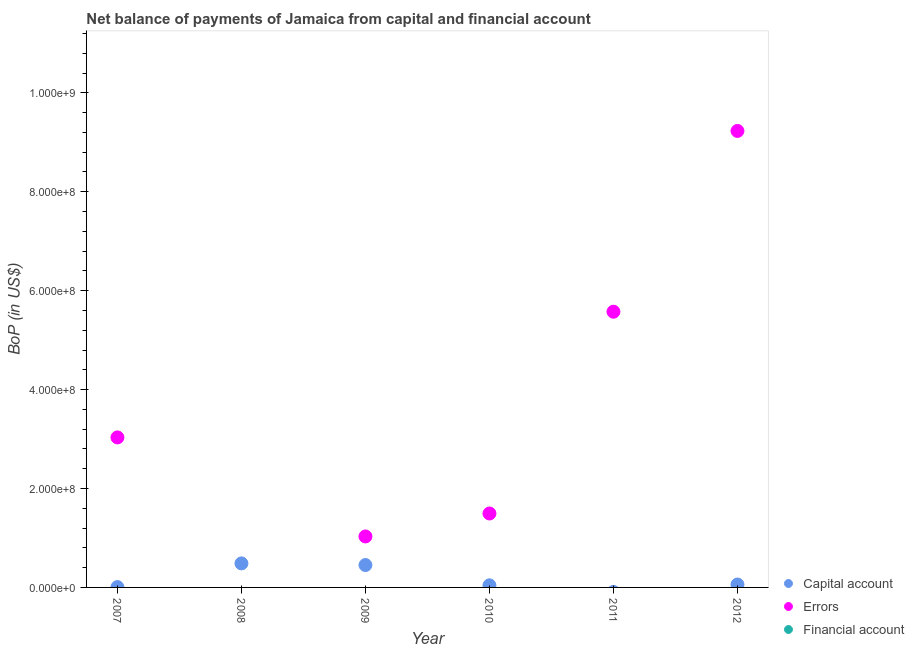Is the number of dotlines equal to the number of legend labels?
Make the answer very short. No. What is the amount of financial account in 2008?
Make the answer very short. 0. Across all years, what is the maximum amount of errors?
Provide a succinct answer. 9.23e+08. What is the total amount of net capital account in the graph?
Provide a succinct answer. 1.05e+08. What is the difference between the amount of errors in 2010 and that in 2012?
Your answer should be very brief. -7.73e+08. What is the difference between the amount of net capital account in 2007 and the amount of errors in 2009?
Offer a very short reply. -1.02e+08. What is the average amount of net capital account per year?
Offer a terse response. 1.74e+07. In the year 2010, what is the difference between the amount of net capital account and amount of errors?
Your answer should be very brief. -1.45e+08. In how many years, is the amount of net capital account greater than 120000000 US$?
Give a very brief answer. 0. What is the ratio of the amount of net capital account in 2008 to that in 2010?
Offer a very short reply. 11.45. What is the difference between the highest and the second highest amount of net capital account?
Keep it short and to the point. 3.31e+06. What is the difference between the highest and the lowest amount of net capital account?
Keep it short and to the point. 4.86e+07. Is it the case that in every year, the sum of the amount of net capital account and amount of errors is greater than the amount of financial account?
Offer a terse response. Yes. Does the amount of errors monotonically increase over the years?
Keep it short and to the point. No. Is the amount of net capital account strictly greater than the amount of financial account over the years?
Ensure brevity in your answer.  Yes. What is the difference between two consecutive major ticks on the Y-axis?
Your answer should be very brief. 2.00e+08. Are the values on the major ticks of Y-axis written in scientific E-notation?
Your answer should be compact. Yes. How many legend labels are there?
Ensure brevity in your answer.  3. What is the title of the graph?
Make the answer very short. Net balance of payments of Jamaica from capital and financial account. Does "Services" appear as one of the legend labels in the graph?
Your answer should be very brief. No. What is the label or title of the Y-axis?
Ensure brevity in your answer.  BoP (in US$). What is the BoP (in US$) in Capital account in 2007?
Make the answer very short. 6.90e+05. What is the BoP (in US$) in Errors in 2007?
Offer a terse response. 3.03e+08. What is the BoP (in US$) in Capital account in 2008?
Your answer should be compact. 4.86e+07. What is the BoP (in US$) in Capital account in 2009?
Give a very brief answer. 4.53e+07. What is the BoP (in US$) of Errors in 2009?
Provide a short and direct response. 1.03e+08. What is the BoP (in US$) in Financial account in 2009?
Provide a succinct answer. 0. What is the BoP (in US$) in Capital account in 2010?
Your answer should be compact. 4.24e+06. What is the BoP (in US$) in Errors in 2010?
Your answer should be very brief. 1.49e+08. What is the BoP (in US$) in Capital account in 2011?
Offer a terse response. 0. What is the BoP (in US$) in Errors in 2011?
Make the answer very short. 5.57e+08. What is the BoP (in US$) in Financial account in 2011?
Make the answer very short. 0. What is the BoP (in US$) of Capital account in 2012?
Offer a terse response. 5.87e+06. What is the BoP (in US$) of Errors in 2012?
Provide a short and direct response. 9.23e+08. What is the BoP (in US$) in Financial account in 2012?
Offer a very short reply. 0. Across all years, what is the maximum BoP (in US$) in Capital account?
Offer a very short reply. 4.86e+07. Across all years, what is the maximum BoP (in US$) in Errors?
Your answer should be very brief. 9.23e+08. Across all years, what is the minimum BoP (in US$) of Capital account?
Provide a succinct answer. 0. What is the total BoP (in US$) of Capital account in the graph?
Keep it short and to the point. 1.05e+08. What is the total BoP (in US$) in Errors in the graph?
Provide a short and direct response. 2.04e+09. What is the total BoP (in US$) in Financial account in the graph?
Provide a short and direct response. 0. What is the difference between the BoP (in US$) of Capital account in 2007 and that in 2008?
Make the answer very short. -4.79e+07. What is the difference between the BoP (in US$) in Capital account in 2007 and that in 2009?
Keep it short and to the point. -4.46e+07. What is the difference between the BoP (in US$) of Errors in 2007 and that in 2009?
Keep it short and to the point. 2.00e+08. What is the difference between the BoP (in US$) in Capital account in 2007 and that in 2010?
Offer a terse response. -3.55e+06. What is the difference between the BoP (in US$) in Errors in 2007 and that in 2010?
Offer a very short reply. 1.54e+08. What is the difference between the BoP (in US$) of Errors in 2007 and that in 2011?
Your answer should be compact. -2.54e+08. What is the difference between the BoP (in US$) in Capital account in 2007 and that in 2012?
Provide a succinct answer. -5.18e+06. What is the difference between the BoP (in US$) in Errors in 2007 and that in 2012?
Keep it short and to the point. -6.20e+08. What is the difference between the BoP (in US$) of Capital account in 2008 and that in 2009?
Provide a short and direct response. 3.31e+06. What is the difference between the BoP (in US$) of Capital account in 2008 and that in 2010?
Make the answer very short. 4.43e+07. What is the difference between the BoP (in US$) in Capital account in 2008 and that in 2012?
Ensure brevity in your answer.  4.27e+07. What is the difference between the BoP (in US$) in Capital account in 2009 and that in 2010?
Ensure brevity in your answer.  4.10e+07. What is the difference between the BoP (in US$) in Errors in 2009 and that in 2010?
Make the answer very short. -4.64e+07. What is the difference between the BoP (in US$) of Errors in 2009 and that in 2011?
Keep it short and to the point. -4.54e+08. What is the difference between the BoP (in US$) in Capital account in 2009 and that in 2012?
Offer a very short reply. 3.94e+07. What is the difference between the BoP (in US$) of Errors in 2009 and that in 2012?
Give a very brief answer. -8.20e+08. What is the difference between the BoP (in US$) in Errors in 2010 and that in 2011?
Provide a succinct answer. -4.08e+08. What is the difference between the BoP (in US$) in Capital account in 2010 and that in 2012?
Ensure brevity in your answer.  -1.63e+06. What is the difference between the BoP (in US$) in Errors in 2010 and that in 2012?
Your answer should be compact. -7.73e+08. What is the difference between the BoP (in US$) of Errors in 2011 and that in 2012?
Your answer should be compact. -3.65e+08. What is the difference between the BoP (in US$) of Capital account in 2007 and the BoP (in US$) of Errors in 2009?
Offer a terse response. -1.02e+08. What is the difference between the BoP (in US$) of Capital account in 2007 and the BoP (in US$) of Errors in 2010?
Your response must be concise. -1.49e+08. What is the difference between the BoP (in US$) in Capital account in 2007 and the BoP (in US$) in Errors in 2011?
Offer a very short reply. -5.57e+08. What is the difference between the BoP (in US$) of Capital account in 2007 and the BoP (in US$) of Errors in 2012?
Give a very brief answer. -9.22e+08. What is the difference between the BoP (in US$) in Capital account in 2008 and the BoP (in US$) in Errors in 2009?
Offer a terse response. -5.45e+07. What is the difference between the BoP (in US$) in Capital account in 2008 and the BoP (in US$) in Errors in 2010?
Keep it short and to the point. -1.01e+08. What is the difference between the BoP (in US$) of Capital account in 2008 and the BoP (in US$) of Errors in 2011?
Your answer should be very brief. -5.09e+08. What is the difference between the BoP (in US$) of Capital account in 2008 and the BoP (in US$) of Errors in 2012?
Your answer should be compact. -8.74e+08. What is the difference between the BoP (in US$) of Capital account in 2009 and the BoP (in US$) of Errors in 2010?
Provide a short and direct response. -1.04e+08. What is the difference between the BoP (in US$) of Capital account in 2009 and the BoP (in US$) of Errors in 2011?
Your answer should be compact. -5.12e+08. What is the difference between the BoP (in US$) of Capital account in 2009 and the BoP (in US$) of Errors in 2012?
Your answer should be very brief. -8.78e+08. What is the difference between the BoP (in US$) of Capital account in 2010 and the BoP (in US$) of Errors in 2011?
Your answer should be very brief. -5.53e+08. What is the difference between the BoP (in US$) of Capital account in 2010 and the BoP (in US$) of Errors in 2012?
Ensure brevity in your answer.  -9.19e+08. What is the average BoP (in US$) in Capital account per year?
Keep it short and to the point. 1.74e+07. What is the average BoP (in US$) of Errors per year?
Offer a very short reply. 3.39e+08. In the year 2007, what is the difference between the BoP (in US$) in Capital account and BoP (in US$) in Errors?
Provide a succinct answer. -3.03e+08. In the year 2009, what is the difference between the BoP (in US$) of Capital account and BoP (in US$) of Errors?
Your answer should be very brief. -5.78e+07. In the year 2010, what is the difference between the BoP (in US$) in Capital account and BoP (in US$) in Errors?
Your answer should be very brief. -1.45e+08. In the year 2012, what is the difference between the BoP (in US$) in Capital account and BoP (in US$) in Errors?
Keep it short and to the point. -9.17e+08. What is the ratio of the BoP (in US$) of Capital account in 2007 to that in 2008?
Make the answer very short. 0.01. What is the ratio of the BoP (in US$) of Capital account in 2007 to that in 2009?
Provide a succinct answer. 0.02. What is the ratio of the BoP (in US$) of Errors in 2007 to that in 2009?
Give a very brief answer. 2.94. What is the ratio of the BoP (in US$) in Capital account in 2007 to that in 2010?
Your answer should be very brief. 0.16. What is the ratio of the BoP (in US$) in Errors in 2007 to that in 2010?
Give a very brief answer. 2.03. What is the ratio of the BoP (in US$) of Errors in 2007 to that in 2011?
Your response must be concise. 0.54. What is the ratio of the BoP (in US$) of Capital account in 2007 to that in 2012?
Ensure brevity in your answer.  0.12. What is the ratio of the BoP (in US$) of Errors in 2007 to that in 2012?
Offer a very short reply. 0.33. What is the ratio of the BoP (in US$) in Capital account in 2008 to that in 2009?
Offer a terse response. 1.07. What is the ratio of the BoP (in US$) of Capital account in 2008 to that in 2010?
Your answer should be very brief. 11.45. What is the ratio of the BoP (in US$) of Capital account in 2008 to that in 2012?
Your response must be concise. 8.27. What is the ratio of the BoP (in US$) of Capital account in 2009 to that in 2010?
Provide a succinct answer. 10.67. What is the ratio of the BoP (in US$) of Errors in 2009 to that in 2010?
Your answer should be very brief. 0.69. What is the ratio of the BoP (in US$) in Errors in 2009 to that in 2011?
Your answer should be compact. 0.18. What is the ratio of the BoP (in US$) in Capital account in 2009 to that in 2012?
Give a very brief answer. 7.71. What is the ratio of the BoP (in US$) of Errors in 2009 to that in 2012?
Your response must be concise. 0.11. What is the ratio of the BoP (in US$) in Errors in 2010 to that in 2011?
Provide a succinct answer. 0.27. What is the ratio of the BoP (in US$) in Capital account in 2010 to that in 2012?
Ensure brevity in your answer.  0.72. What is the ratio of the BoP (in US$) of Errors in 2010 to that in 2012?
Provide a succinct answer. 0.16. What is the ratio of the BoP (in US$) of Errors in 2011 to that in 2012?
Your answer should be compact. 0.6. What is the difference between the highest and the second highest BoP (in US$) in Capital account?
Keep it short and to the point. 3.31e+06. What is the difference between the highest and the second highest BoP (in US$) in Errors?
Your answer should be compact. 3.65e+08. What is the difference between the highest and the lowest BoP (in US$) of Capital account?
Give a very brief answer. 4.86e+07. What is the difference between the highest and the lowest BoP (in US$) of Errors?
Ensure brevity in your answer.  9.23e+08. 